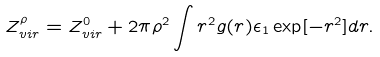Convert formula to latex. <formula><loc_0><loc_0><loc_500><loc_500>Z _ { v i r } ^ { \rho } = Z _ { v i r } ^ { 0 } + 2 \pi \rho ^ { 2 } \int r ^ { 2 } g ( r ) \epsilon _ { 1 } \exp [ - r ^ { 2 } ] d r .</formula> 